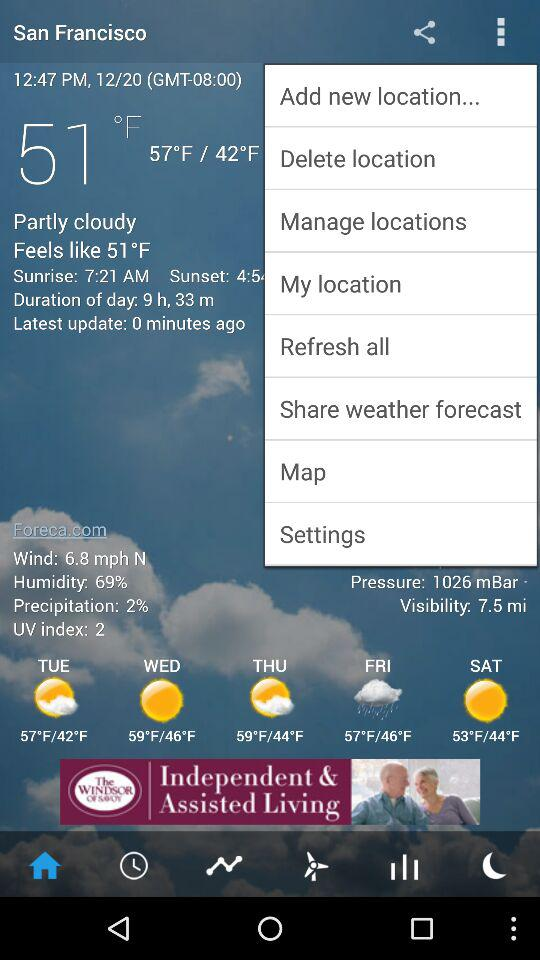On which days is there a chance of rain? There is a chance of rain on Friday. 